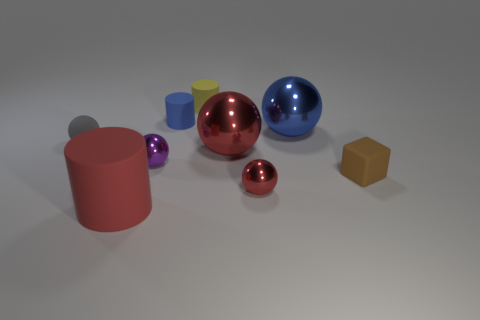Are there an equal number of rubber cylinders behind the big red shiny ball and small gray shiny objects?
Make the answer very short. No. How many blocks are big red rubber things or tiny gray things?
Your answer should be compact. 0. Is the color of the matte block the same as the rubber ball?
Offer a very short reply. No. Is the number of red matte cylinders to the right of the purple ball the same as the number of tiny yellow cylinders that are left of the large red cylinder?
Give a very brief answer. Yes. The matte ball is what color?
Ensure brevity in your answer.  Gray. What number of things are either red things that are right of the big red matte object or large metal things?
Make the answer very short. 3. Is the size of the red metallic thing behind the small purple metal sphere the same as the object that is to the left of the red rubber cylinder?
Provide a short and direct response. No. Is there anything else that has the same material as the small yellow cylinder?
Ensure brevity in your answer.  Yes. What number of things are either tiny balls right of the tiny purple metal sphere or tiny red metallic spheres in front of the yellow thing?
Provide a short and direct response. 1. Are the small gray sphere and the red ball to the right of the big red sphere made of the same material?
Offer a very short reply. No. 